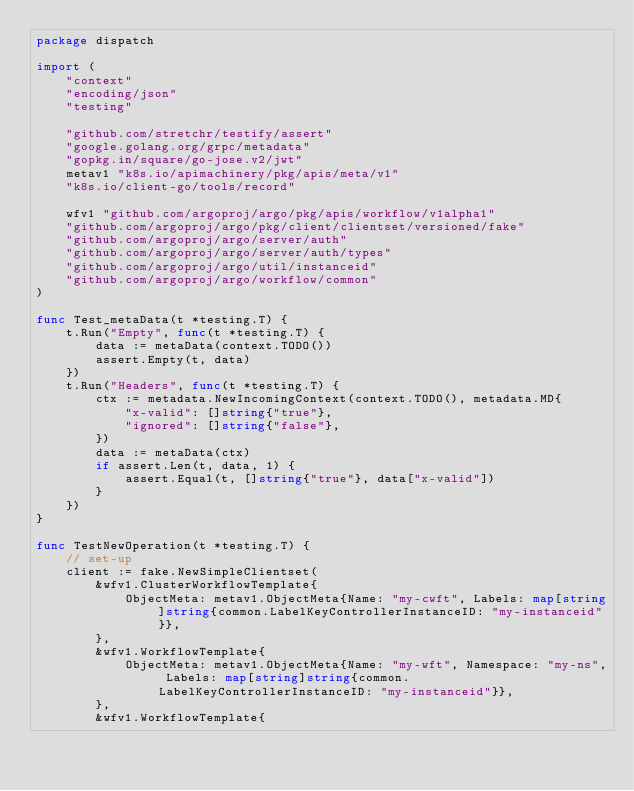<code> <loc_0><loc_0><loc_500><loc_500><_Go_>package dispatch

import (
	"context"
	"encoding/json"
	"testing"

	"github.com/stretchr/testify/assert"
	"google.golang.org/grpc/metadata"
	"gopkg.in/square/go-jose.v2/jwt"
	metav1 "k8s.io/apimachinery/pkg/apis/meta/v1"
	"k8s.io/client-go/tools/record"

	wfv1 "github.com/argoproj/argo/pkg/apis/workflow/v1alpha1"
	"github.com/argoproj/argo/pkg/client/clientset/versioned/fake"
	"github.com/argoproj/argo/server/auth"
	"github.com/argoproj/argo/server/auth/types"
	"github.com/argoproj/argo/util/instanceid"
	"github.com/argoproj/argo/workflow/common"
)

func Test_metaData(t *testing.T) {
	t.Run("Empty", func(t *testing.T) {
		data := metaData(context.TODO())
		assert.Empty(t, data)
	})
	t.Run("Headers", func(t *testing.T) {
		ctx := metadata.NewIncomingContext(context.TODO(), metadata.MD{
			"x-valid": []string{"true"},
			"ignored": []string{"false"},
		})
		data := metaData(ctx)
		if assert.Len(t, data, 1) {
			assert.Equal(t, []string{"true"}, data["x-valid"])
		}
	})
}

func TestNewOperation(t *testing.T) {
	// set-up
	client := fake.NewSimpleClientset(
		&wfv1.ClusterWorkflowTemplate{
			ObjectMeta: metav1.ObjectMeta{Name: "my-cwft", Labels: map[string]string{common.LabelKeyControllerInstanceID: "my-instanceid"}},
		},
		&wfv1.WorkflowTemplate{
			ObjectMeta: metav1.ObjectMeta{Name: "my-wft", Namespace: "my-ns", Labels: map[string]string{common.LabelKeyControllerInstanceID: "my-instanceid"}},
		},
		&wfv1.WorkflowTemplate{</code> 